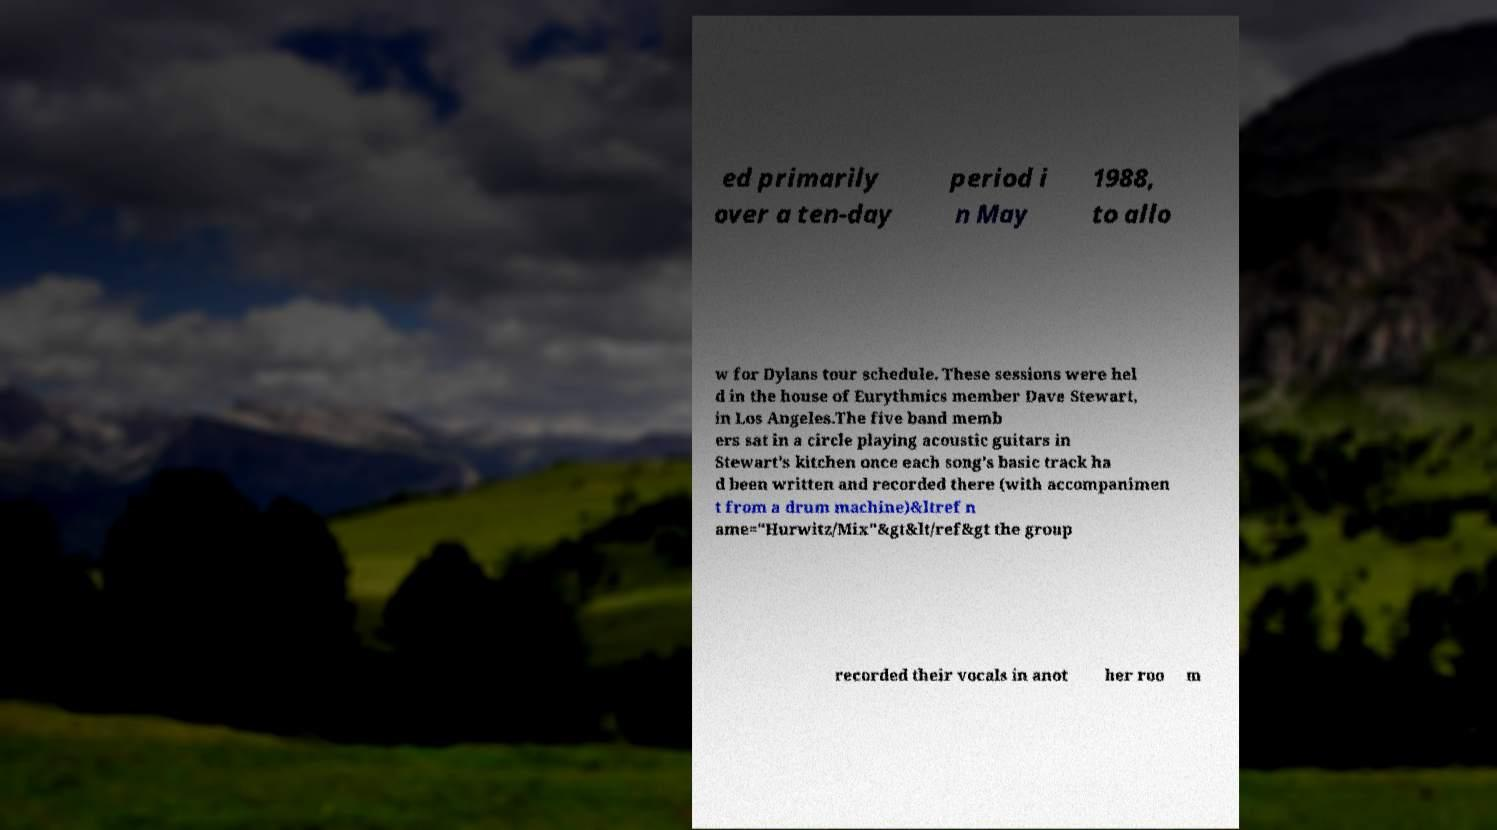What messages or text are displayed in this image? I need them in a readable, typed format. ed primarily over a ten-day period i n May 1988, to allo w for Dylans tour schedule. These sessions were hel d in the house of Eurythmics member Dave Stewart, in Los Angeles.The five band memb ers sat in a circle playing acoustic guitars in Stewart's kitchen once each song's basic track ha d been written and recorded there (with accompanimen t from a drum machine)&ltref n ame="Hurwitz/Mix"&gt&lt/ref&gt the group recorded their vocals in anot her roo m 